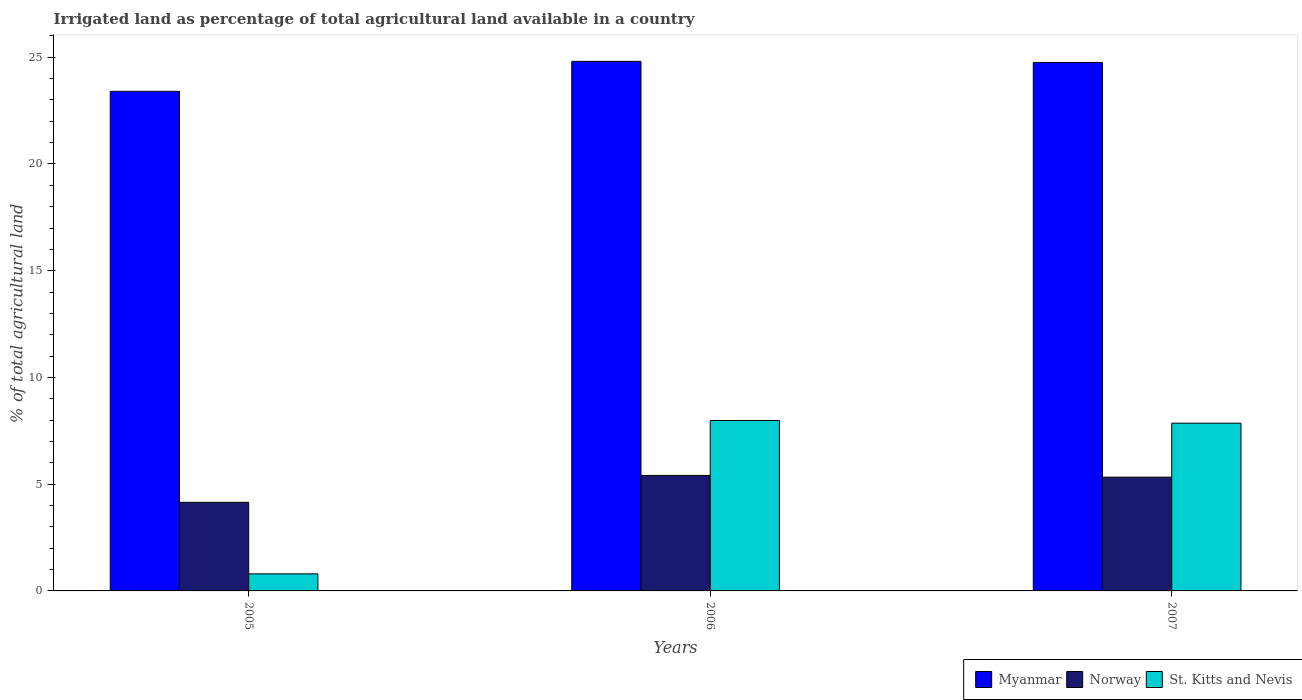Are the number of bars per tick equal to the number of legend labels?
Ensure brevity in your answer.  Yes. How many bars are there on the 2nd tick from the left?
Keep it short and to the point. 3. What is the label of the 3rd group of bars from the left?
Offer a very short reply. 2007. In how many cases, is the number of bars for a given year not equal to the number of legend labels?
Your answer should be compact. 0. What is the percentage of irrigated land in Myanmar in 2005?
Offer a very short reply. 23.4. Across all years, what is the maximum percentage of irrigated land in St. Kitts and Nevis?
Ensure brevity in your answer.  7.98. Across all years, what is the minimum percentage of irrigated land in Myanmar?
Keep it short and to the point. 23.4. What is the total percentage of irrigated land in Norway in the graph?
Offer a terse response. 14.89. What is the difference between the percentage of irrigated land in Myanmar in 2005 and that in 2006?
Ensure brevity in your answer.  -1.4. What is the difference between the percentage of irrigated land in Myanmar in 2005 and the percentage of irrigated land in Norway in 2006?
Your answer should be very brief. 17.99. What is the average percentage of irrigated land in Norway per year?
Your answer should be very brief. 4.96. In the year 2005, what is the difference between the percentage of irrigated land in Myanmar and percentage of irrigated land in St. Kitts and Nevis?
Ensure brevity in your answer.  22.6. In how many years, is the percentage of irrigated land in St. Kitts and Nevis greater than 3 %?
Provide a succinct answer. 2. What is the ratio of the percentage of irrigated land in St. Kitts and Nevis in 2006 to that in 2007?
Offer a very short reply. 1.02. Is the difference between the percentage of irrigated land in Myanmar in 2005 and 2007 greater than the difference between the percentage of irrigated land in St. Kitts and Nevis in 2005 and 2007?
Keep it short and to the point. Yes. What is the difference between the highest and the second highest percentage of irrigated land in St. Kitts and Nevis?
Offer a very short reply. 0.13. What is the difference between the highest and the lowest percentage of irrigated land in Norway?
Keep it short and to the point. 1.26. In how many years, is the percentage of irrigated land in Myanmar greater than the average percentage of irrigated land in Myanmar taken over all years?
Your answer should be compact. 2. Is the sum of the percentage of irrigated land in Norway in 2006 and 2007 greater than the maximum percentage of irrigated land in Myanmar across all years?
Give a very brief answer. No. What does the 3rd bar from the left in 2005 represents?
Provide a short and direct response. St. Kitts and Nevis. What does the 3rd bar from the right in 2006 represents?
Your answer should be very brief. Myanmar. Are all the bars in the graph horizontal?
Offer a very short reply. No. What is the difference between two consecutive major ticks on the Y-axis?
Your answer should be compact. 5. Does the graph contain any zero values?
Your answer should be very brief. No. Does the graph contain grids?
Provide a succinct answer. No. Where does the legend appear in the graph?
Make the answer very short. Bottom right. How many legend labels are there?
Ensure brevity in your answer.  3. What is the title of the graph?
Your response must be concise. Irrigated land as percentage of total agricultural land available in a country. What is the label or title of the Y-axis?
Keep it short and to the point. % of total agricultural land. What is the % of total agricultural land in Myanmar in 2005?
Make the answer very short. 23.4. What is the % of total agricultural land of Norway in 2005?
Ensure brevity in your answer.  4.15. What is the % of total agricultural land of St. Kitts and Nevis in 2005?
Ensure brevity in your answer.  0.8. What is the % of total agricultural land in Myanmar in 2006?
Give a very brief answer. 24.81. What is the % of total agricultural land in Norway in 2006?
Provide a short and direct response. 5.41. What is the % of total agricultural land in St. Kitts and Nevis in 2006?
Your response must be concise. 7.98. What is the % of total agricultural land in Myanmar in 2007?
Ensure brevity in your answer.  24.76. What is the % of total agricultural land in Norway in 2007?
Provide a succinct answer. 5.33. What is the % of total agricultural land in St. Kitts and Nevis in 2007?
Ensure brevity in your answer.  7.86. Across all years, what is the maximum % of total agricultural land in Myanmar?
Keep it short and to the point. 24.81. Across all years, what is the maximum % of total agricultural land of Norway?
Your answer should be very brief. 5.41. Across all years, what is the maximum % of total agricultural land of St. Kitts and Nevis?
Give a very brief answer. 7.98. Across all years, what is the minimum % of total agricultural land in Myanmar?
Make the answer very short. 23.4. Across all years, what is the minimum % of total agricultural land of Norway?
Offer a very short reply. 4.15. What is the total % of total agricultural land of Myanmar in the graph?
Give a very brief answer. 72.97. What is the total % of total agricultural land in Norway in the graph?
Your response must be concise. 14.89. What is the total % of total agricultural land of St. Kitts and Nevis in the graph?
Provide a short and direct response. 16.64. What is the difference between the % of total agricultural land in Myanmar in 2005 and that in 2006?
Give a very brief answer. -1.4. What is the difference between the % of total agricultural land in Norway in 2005 and that in 2006?
Provide a succinct answer. -1.26. What is the difference between the % of total agricultural land of St. Kitts and Nevis in 2005 and that in 2006?
Keep it short and to the point. -7.18. What is the difference between the % of total agricultural land in Myanmar in 2005 and that in 2007?
Give a very brief answer. -1.35. What is the difference between the % of total agricultural land of Norway in 2005 and that in 2007?
Give a very brief answer. -1.18. What is the difference between the % of total agricultural land of St. Kitts and Nevis in 2005 and that in 2007?
Your response must be concise. -7.06. What is the difference between the % of total agricultural land of Myanmar in 2006 and that in 2007?
Ensure brevity in your answer.  0.05. What is the difference between the % of total agricultural land in Norway in 2006 and that in 2007?
Your answer should be very brief. 0.08. What is the difference between the % of total agricultural land of St. Kitts and Nevis in 2006 and that in 2007?
Keep it short and to the point. 0.13. What is the difference between the % of total agricultural land in Myanmar in 2005 and the % of total agricultural land in Norway in 2006?
Keep it short and to the point. 17.99. What is the difference between the % of total agricultural land of Myanmar in 2005 and the % of total agricultural land of St. Kitts and Nevis in 2006?
Your answer should be very brief. 15.42. What is the difference between the % of total agricultural land in Norway in 2005 and the % of total agricultural land in St. Kitts and Nevis in 2006?
Offer a very short reply. -3.83. What is the difference between the % of total agricultural land of Myanmar in 2005 and the % of total agricultural land of Norway in 2007?
Ensure brevity in your answer.  18.07. What is the difference between the % of total agricultural land of Myanmar in 2005 and the % of total agricultural land of St. Kitts and Nevis in 2007?
Offer a terse response. 15.55. What is the difference between the % of total agricultural land of Norway in 2005 and the % of total agricultural land of St. Kitts and Nevis in 2007?
Keep it short and to the point. -3.71. What is the difference between the % of total agricultural land of Myanmar in 2006 and the % of total agricultural land of Norway in 2007?
Provide a succinct answer. 19.48. What is the difference between the % of total agricultural land of Myanmar in 2006 and the % of total agricultural land of St. Kitts and Nevis in 2007?
Give a very brief answer. 16.95. What is the difference between the % of total agricultural land in Norway in 2006 and the % of total agricultural land in St. Kitts and Nevis in 2007?
Offer a very short reply. -2.45. What is the average % of total agricultural land in Myanmar per year?
Your response must be concise. 24.32. What is the average % of total agricultural land of Norway per year?
Offer a terse response. 4.96. What is the average % of total agricultural land in St. Kitts and Nevis per year?
Give a very brief answer. 5.55. In the year 2005, what is the difference between the % of total agricultural land of Myanmar and % of total agricultural land of Norway?
Give a very brief answer. 19.25. In the year 2005, what is the difference between the % of total agricultural land in Myanmar and % of total agricultural land in St. Kitts and Nevis?
Your response must be concise. 22.6. In the year 2005, what is the difference between the % of total agricultural land of Norway and % of total agricultural land of St. Kitts and Nevis?
Provide a short and direct response. 3.35. In the year 2006, what is the difference between the % of total agricultural land in Myanmar and % of total agricultural land in Norway?
Ensure brevity in your answer.  19.4. In the year 2006, what is the difference between the % of total agricultural land of Myanmar and % of total agricultural land of St. Kitts and Nevis?
Offer a terse response. 16.82. In the year 2006, what is the difference between the % of total agricultural land in Norway and % of total agricultural land in St. Kitts and Nevis?
Give a very brief answer. -2.57. In the year 2007, what is the difference between the % of total agricultural land of Myanmar and % of total agricultural land of Norway?
Your answer should be compact. 19.43. In the year 2007, what is the difference between the % of total agricultural land of Myanmar and % of total agricultural land of St. Kitts and Nevis?
Offer a terse response. 16.9. In the year 2007, what is the difference between the % of total agricultural land in Norway and % of total agricultural land in St. Kitts and Nevis?
Offer a terse response. -2.53. What is the ratio of the % of total agricultural land of Myanmar in 2005 to that in 2006?
Offer a terse response. 0.94. What is the ratio of the % of total agricultural land of Norway in 2005 to that in 2006?
Offer a terse response. 0.77. What is the ratio of the % of total agricultural land of St. Kitts and Nevis in 2005 to that in 2006?
Offer a terse response. 0.1. What is the ratio of the % of total agricultural land of Myanmar in 2005 to that in 2007?
Make the answer very short. 0.95. What is the ratio of the % of total agricultural land in Norway in 2005 to that in 2007?
Provide a short and direct response. 0.78. What is the ratio of the % of total agricultural land of St. Kitts and Nevis in 2005 to that in 2007?
Keep it short and to the point. 0.1. What is the ratio of the % of total agricultural land in Norway in 2006 to that in 2007?
Give a very brief answer. 1.02. What is the difference between the highest and the second highest % of total agricultural land of Myanmar?
Ensure brevity in your answer.  0.05. What is the difference between the highest and the second highest % of total agricultural land of Norway?
Your answer should be very brief. 0.08. What is the difference between the highest and the second highest % of total agricultural land in St. Kitts and Nevis?
Your answer should be compact. 0.13. What is the difference between the highest and the lowest % of total agricultural land in Myanmar?
Provide a short and direct response. 1.4. What is the difference between the highest and the lowest % of total agricultural land of Norway?
Make the answer very short. 1.26. What is the difference between the highest and the lowest % of total agricultural land of St. Kitts and Nevis?
Offer a terse response. 7.18. 